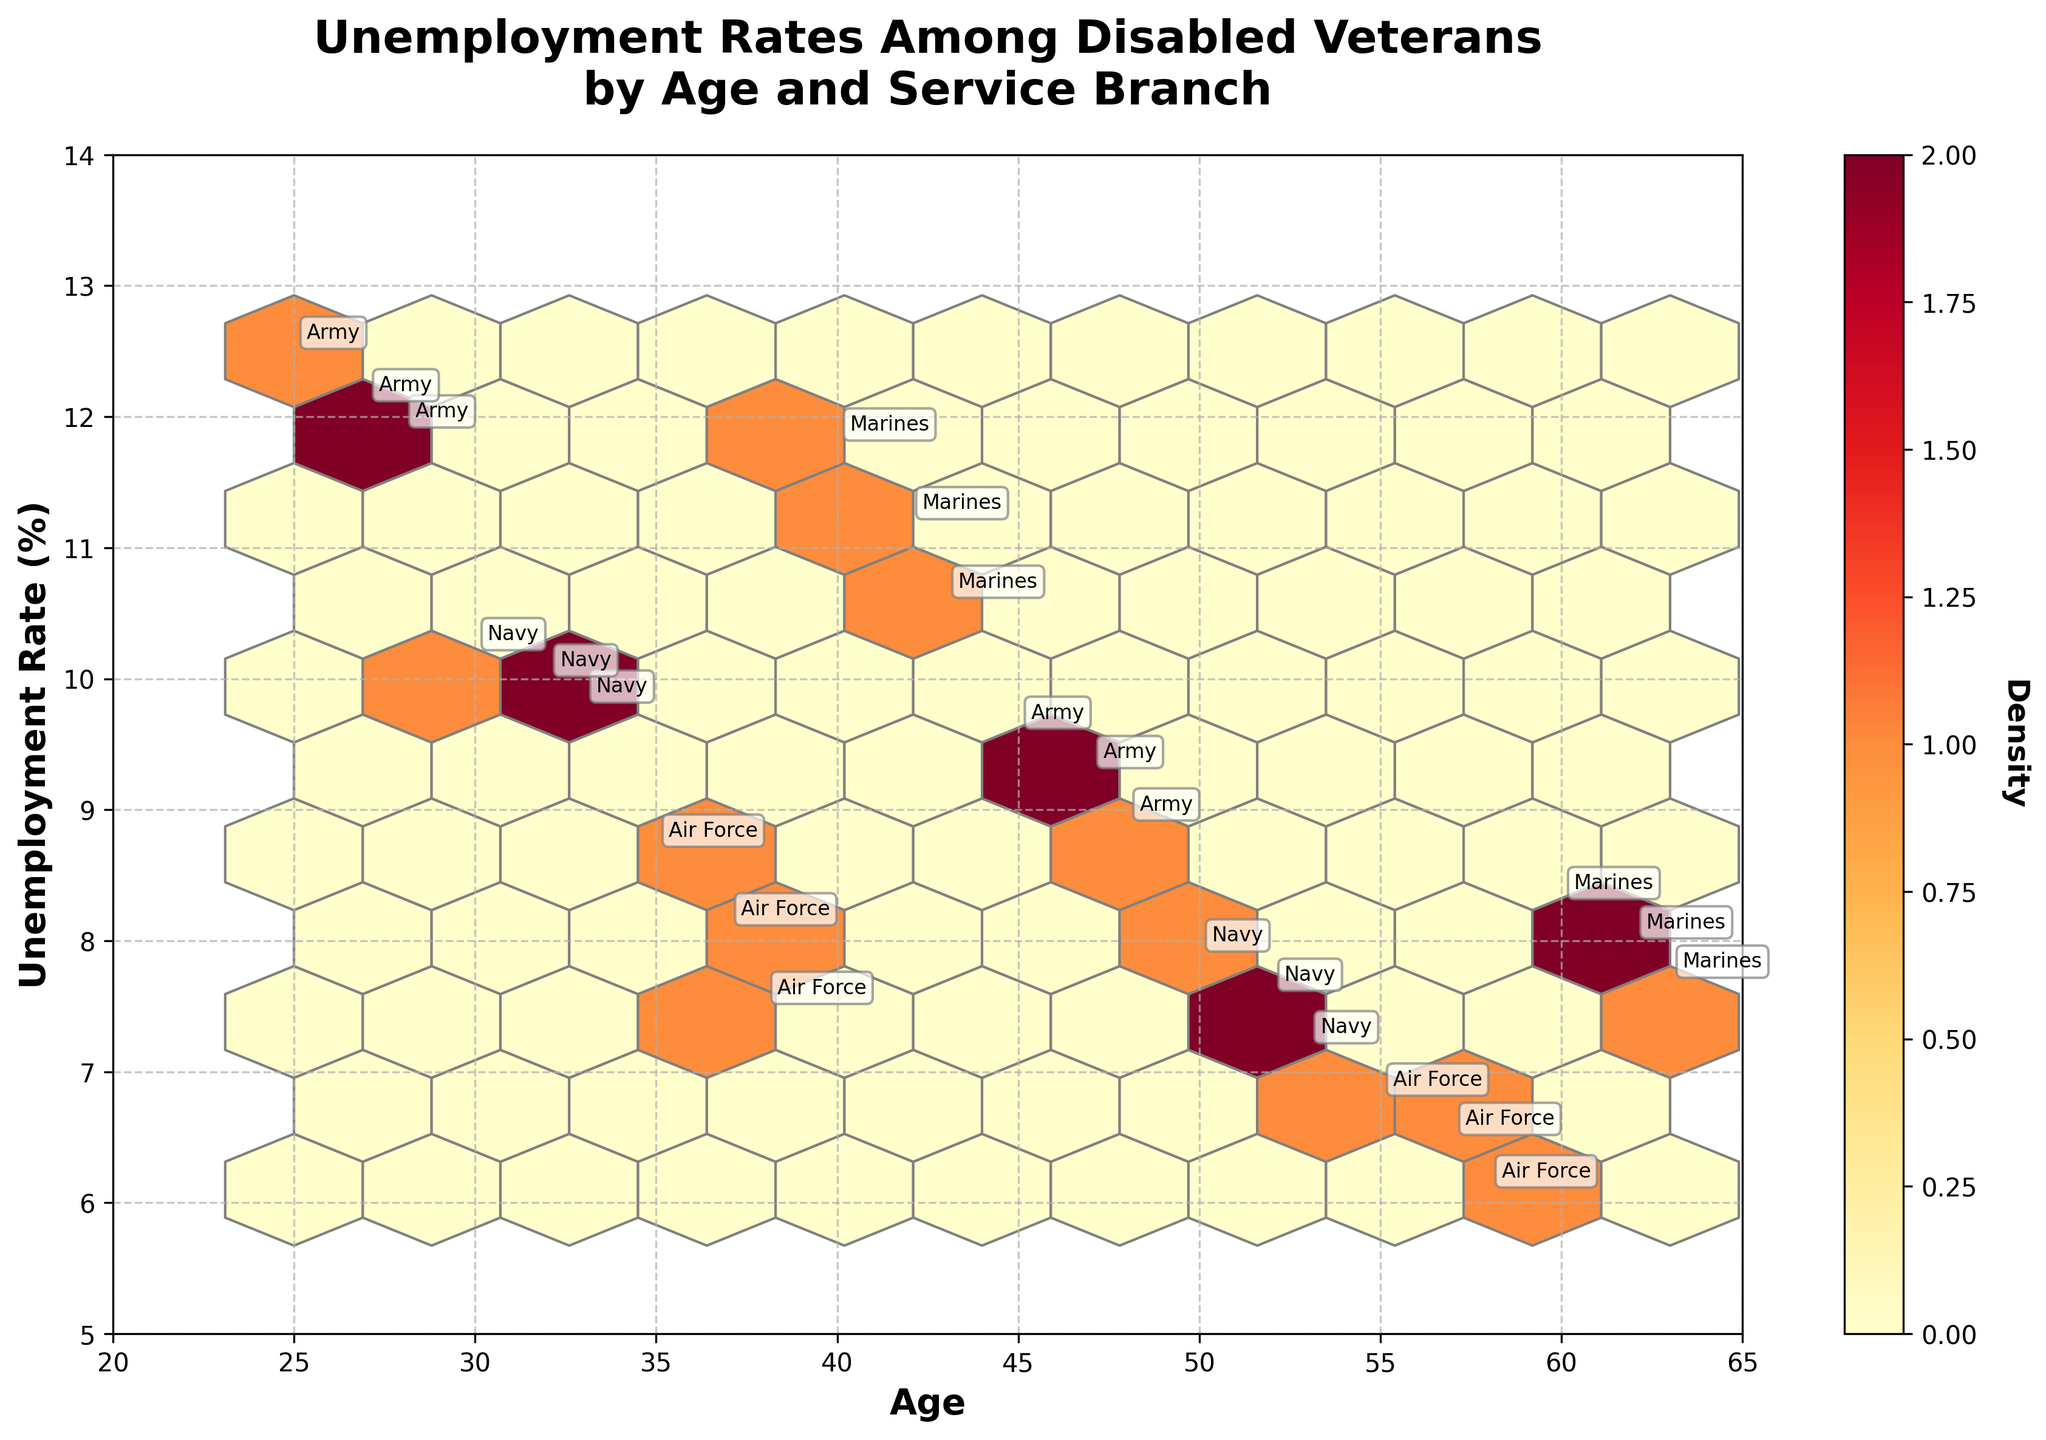What's the title of the figure? The title is usually positioned at the top of the figure in larger, bold font. It provides a summary of the content in the plot. For this plot, it is "Unemployment Rates Among Disabled Veterans by Age and Service Branch".
Answer: Unemployment Rates Among Disabled Veterans by Age and Service Branch What are the labels of the x-axis and y-axis? The x-axis label describes the horizontal axis and the y-axis label describes the vertical axis. In this plot, the x-axis label is "Age" and the y-axis label is "Unemployment Rate (%)".
Answer: Age; Unemployment Rate (%) Which service branch has the highest unemployment rate and what is that rate? To find this, look for the data points annotated with service branch names and identify the one with the highest unemployment rate value on the y-axis. The highest value is for the Army at age 25 with an unemployment rate of 12.5%.
Answer: Army, 12.5% What is the average unemployment rate for veterans aged 40 and above? Identify the unemployment rates for ages 40, 43, 45, 47, 48, 50, 52, 53, 55, 57, 58, 60, 62, and 63. Sum these rates and divide by the number of data points. (11.8 + 10.6 + 9.6 + 9.3 + 8.9 + 7.9 + 7.6 + 7.2 + 6.8 + 6.5 + 6.1 + 8.3 + 8.0 + 7.7) / 14 = 8.26%.
Answer: 8.26% Which age group has the highest density of data points? In a hexbin plot, higher densities are represented by darker colors. Looking at the color density, the age group around 40 to 50 appears to have the highest density.
Answer: 40-50 What is the trend of unemployment rates with increasing age? Observing the overall distribution of the data points, unemployment rates tend to decrease with increasing age. Early ages have higher rates (above 10%), while older ages have lower rates (below 8%).
Answer: Decreasing Which age has the lowest unemployment rate and which service branch does it belong to? Look for the data point with the lowest value on the y-axis. The lowest unemployment rate is at age 58 for the Air Force with a rate of 6.1%.
Answer: 58, Air Force How does the unemployment rate of Navy veterans compare between ages 30 and 50? For Navy veterans, find the data points at ages 30 and 50. The rates are 10.2% and 7.9% respectively. The rate at age 50 is lower by 2.3%.
Answer: Age 50 is lower by 2.3% Which service branch shows the most consistent unemployment rate across different age groups? Consistent rates mean less variability. Air Force shows the most consistency with rates from 6.1% to 8.7%, relatively close compared to other branches.
Answer: Air Force 